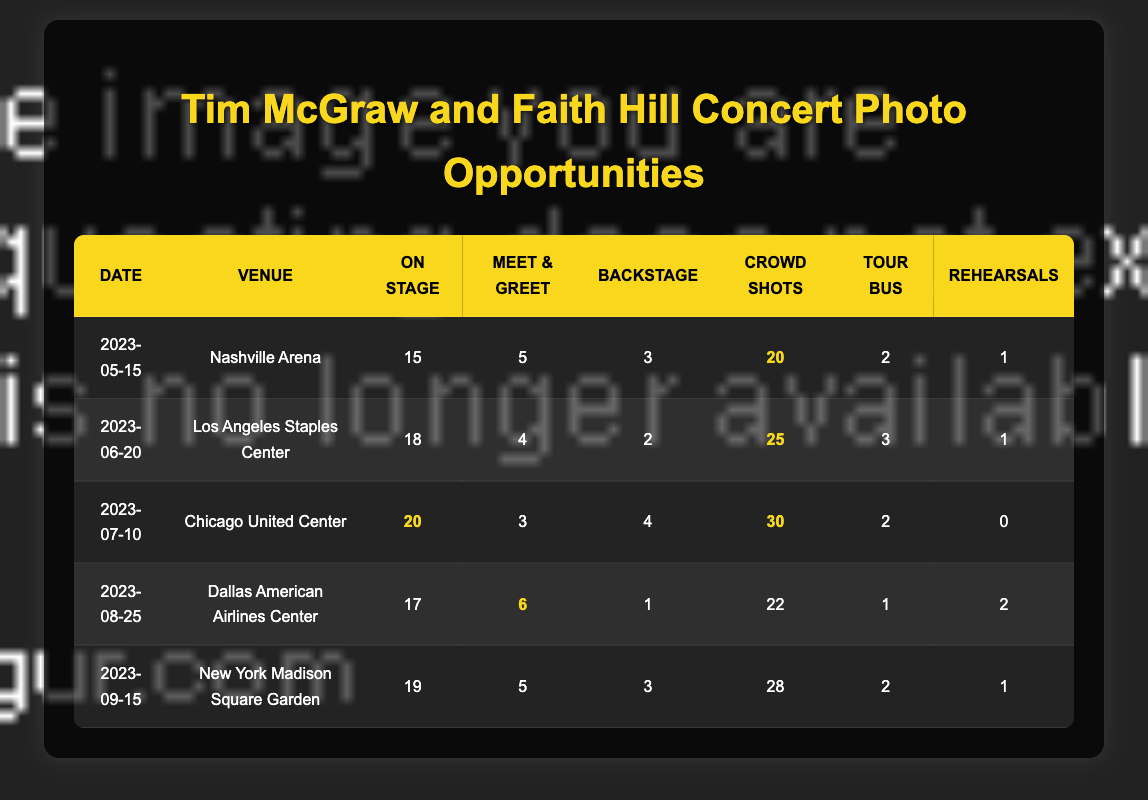What is the maximum number of crowd shots available at any concert? Looking through the "crowd shots" column, the maximum number is 30 at the Chicago United Center concert on 2023-07-10.
Answer: 30 What is the total number of on-stage performance opportunities across all concerts? To find the total, we add: 15 (Nashville) + 18 (Los Angeles) + 20 (Chicago) + 17 (Dallas) + 19 (New York) = 89.
Answer: 89 Was there a concert with zero rehearsal opportunities? Referring to the "rehearsals" column, the Chicago concert on 2023-07-10 has zero rehearsal opportunities.
Answer: Yes How many meet-and-greet opportunities were available at the Los Angeles concert? The table shows that there were 4 meet-and-greet opportunities at the Los Angeles Staples Center concert on 2023-06-20.
Answer: 4 Which concert had the highest number of total photo opportunities? Calculate total opportunities for each concert: Nashville (15+5+3+20+2+1=46), Los Angeles (18+4+2+25+3+1=53), Chicago (20+3+4+30+2+0=59), Dallas (17+6+1+22+1+2=49), New York (19+5+3+28+2+1=58). The highest is 59 at the Chicago concert.
Answer: Chicago United Center What is the average number of backstage access opportunities across all concerts? There are 5 concerts, and the backstage access counts are: 3 (Nashville), 2 (Los Angeles), 4 (Chicago), 1 (Dallas), 3 (New York). Adding these gives 3 + 2 + 4 + 1 + 3 = 13. Thus, the average is 13/5 = 2.6.
Answer: 2.6 If we consider only the concerts with more than 4 meet-and-greet opportunities, which venue had the most crowd shots? The concerts with more than 4 meet-and-greet opportunities are: Nashville (5 crowd shots), Los Angeles (25), Chicago (30), Dallas (6, 22 crowd shots), New York (5, 28 crowd shots). Among these, Chicago had the most crowd shots with 30.
Answer: Chicago United Center How many opportunities were available for tour bus arrivals at the concert in Dallas? The Dallas concert on 2023-08-25 had 1 opportunity listed for tour bus arrivals according to the table.
Answer: 1 What is the number of total photo opportunities for the New York concert compared to the Dallas concert? The total for New York is 19 (on stage) + 5 (meet and greet) + 3 (backstage) + 28 (crowd) + 2 (tour bus) + 1 (rehearsals) = 58. The total for Dallas is 17 + 6 + 1 + 22 + 1 + 2 = 49. New York has 9 more opportunities than Dallas (58 - 49 = 9).
Answer: New York has 9 more opportunities 